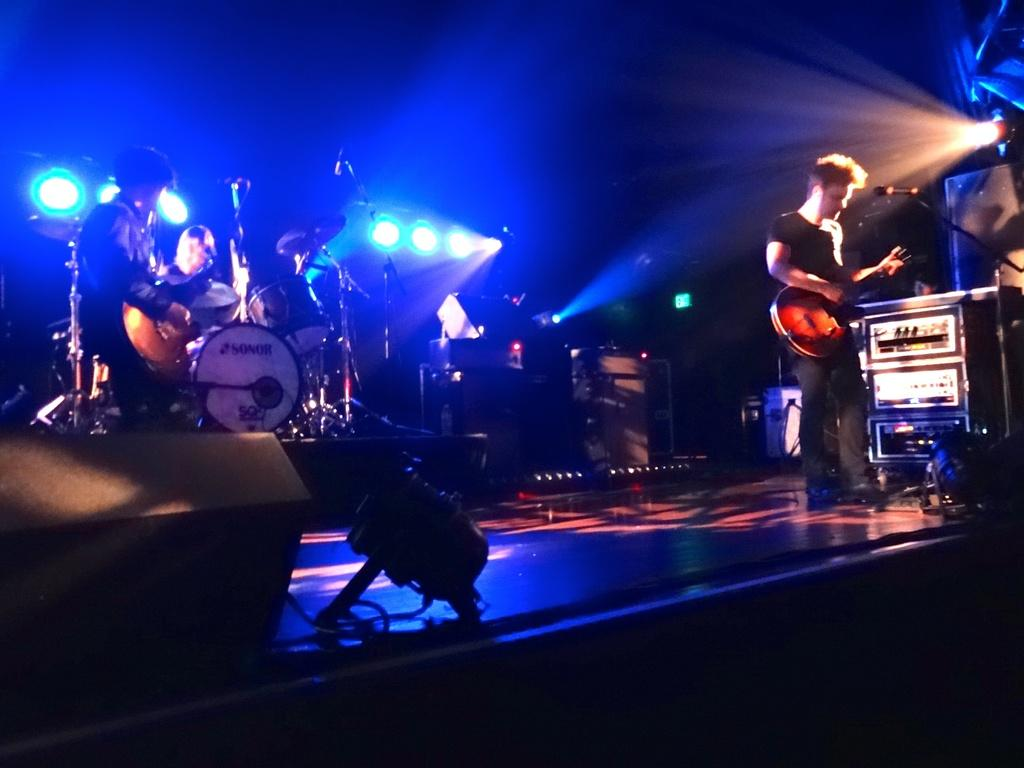What type of lights are visible in the image? There are focusing lights in the image. What are the two persons in the image doing? They are playing guitar in the image. Can you describe the man in the image? There is a man playing a musical instrument in the image. What else can be seen in the image besides the people and lights? There are devices present in the image. Are there any pets visible in the image? There are no pets present in the image. What type of banana is being used as a musical instrument in the image? There is no banana present in the image, let alone being used as a musical instrument. 